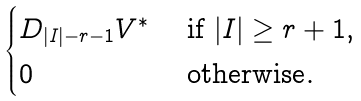Convert formula to latex. <formula><loc_0><loc_0><loc_500><loc_500>\begin{cases} D _ { | I | - r - 1 } V ^ { * } & \text { if } | I | \geq r + 1 , \\ 0 & \text { otherwise} . \end{cases}</formula> 